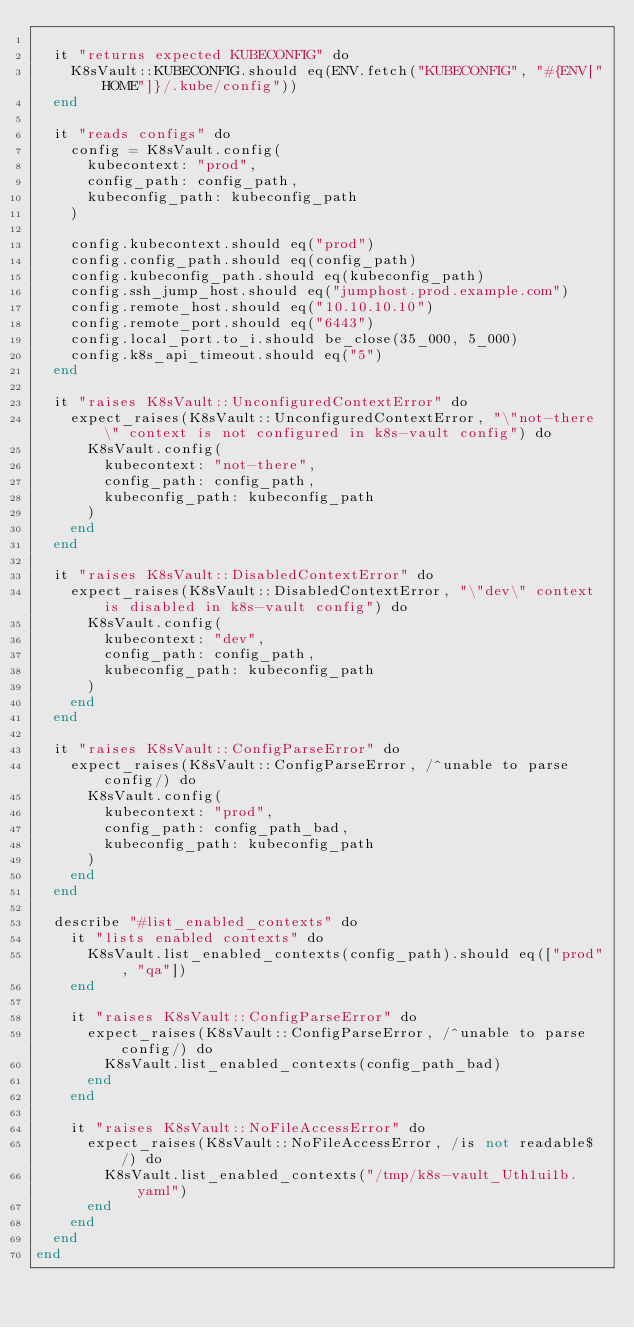Convert code to text. <code><loc_0><loc_0><loc_500><loc_500><_Crystal_>
  it "returns expected KUBECONFIG" do
    K8sVault::KUBECONFIG.should eq(ENV.fetch("KUBECONFIG", "#{ENV["HOME"]}/.kube/config"))
  end

  it "reads configs" do
    config = K8sVault.config(
      kubecontext: "prod",
      config_path: config_path,
      kubeconfig_path: kubeconfig_path
    )

    config.kubecontext.should eq("prod")
    config.config_path.should eq(config_path)
    config.kubeconfig_path.should eq(kubeconfig_path)
    config.ssh_jump_host.should eq("jumphost.prod.example.com")
    config.remote_host.should eq("10.10.10.10")
    config.remote_port.should eq("6443")
    config.local_port.to_i.should be_close(35_000, 5_000)
    config.k8s_api_timeout.should eq("5")
  end

  it "raises K8sVault::UnconfiguredContextError" do
    expect_raises(K8sVault::UnconfiguredContextError, "\"not-there\" context is not configured in k8s-vault config") do
      K8sVault.config(
        kubecontext: "not-there",
        config_path: config_path,
        kubeconfig_path: kubeconfig_path
      )
    end
  end

  it "raises K8sVault::DisabledContextError" do
    expect_raises(K8sVault::DisabledContextError, "\"dev\" context is disabled in k8s-vault config") do
      K8sVault.config(
        kubecontext: "dev",
        config_path: config_path,
        kubeconfig_path: kubeconfig_path
      )
    end
  end

  it "raises K8sVault::ConfigParseError" do
    expect_raises(K8sVault::ConfigParseError, /^unable to parse config/) do
      K8sVault.config(
        kubecontext: "prod",
        config_path: config_path_bad,
        kubeconfig_path: kubeconfig_path
      )
    end
  end

  describe "#list_enabled_contexts" do
    it "lists enabled contexts" do
      K8sVault.list_enabled_contexts(config_path).should eq(["prod", "qa"])
    end

    it "raises K8sVault::ConfigParseError" do
      expect_raises(K8sVault::ConfigParseError, /^unable to parse config/) do
        K8sVault.list_enabled_contexts(config_path_bad)
      end
    end

    it "raises K8sVault::NoFileAccessError" do
      expect_raises(K8sVault::NoFileAccessError, /is not readable$/) do
        K8sVault.list_enabled_contexts("/tmp/k8s-vault_Uth1ui1b.yaml")
      end
    end
  end
end
</code> 